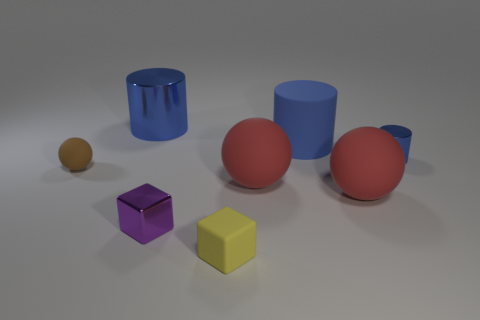What time of day does the lighting suggest? The lighting in the image seems neutral and doesn’t strongly suggest a specific time of day. It's likely rendered with studio lighting to highlight the objects without casting strong shadows. 